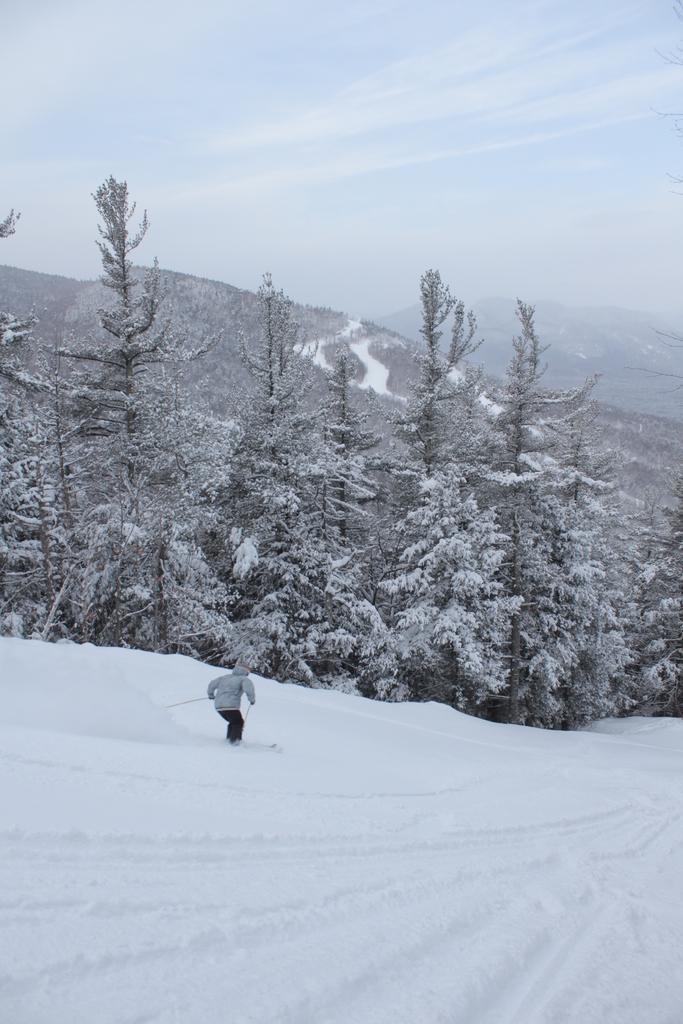In one or two sentences, can you explain what this image depicts? In this image we can see a person skiing on the snow, trees covered with snow, mountains and sky with clouds. 